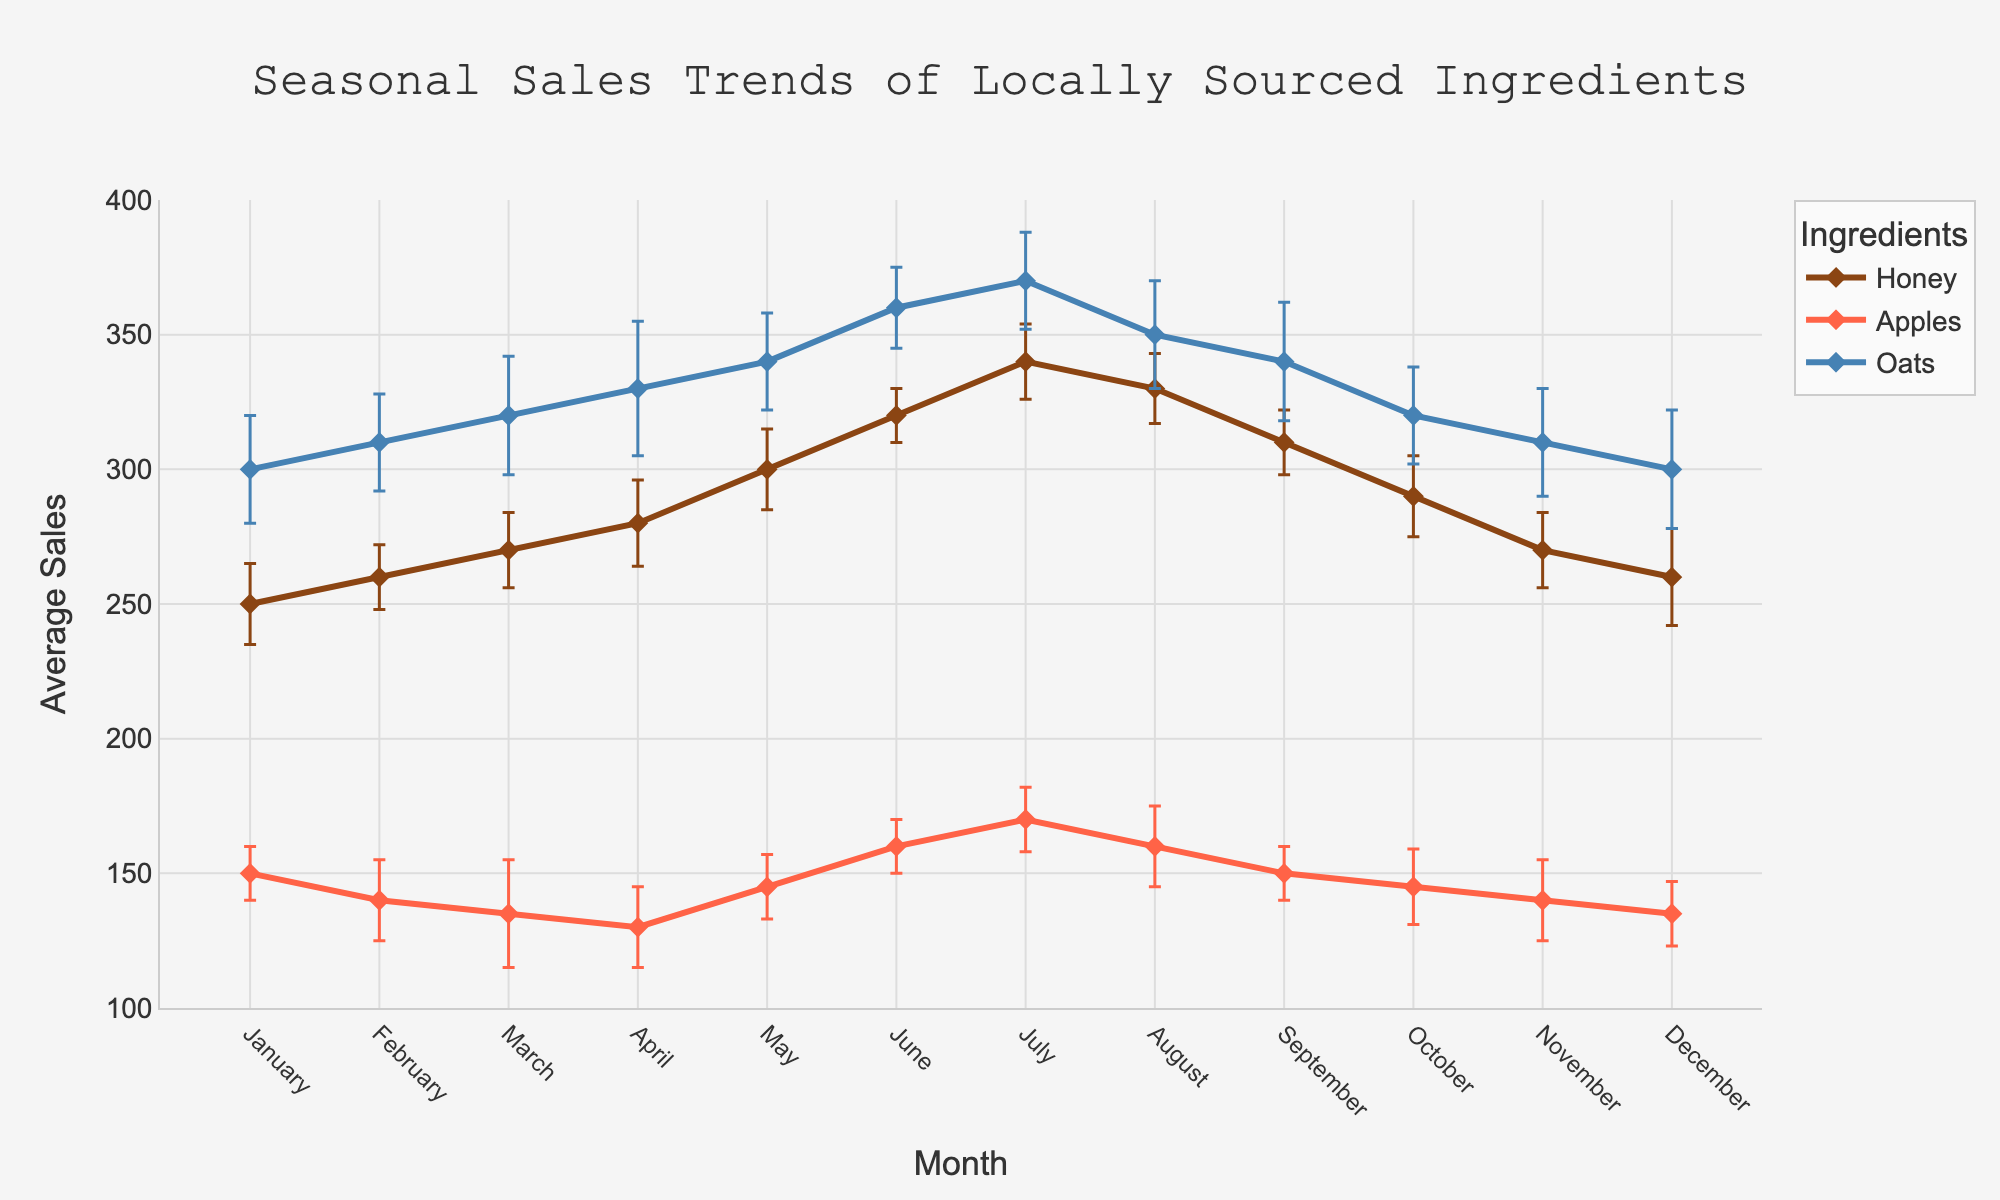what is the title of the figure? The title is located at the top-center of the figure in a larger font size and a different color than the other text. It provides the main information about what the figure represents.
Answer: Seasonal Sales Trends of Locally Sourced Ingredients Which ingredient has the highest average sales in June? Locate the data points for June and identify the ingredient with the highest vertical position on the y-axis. This represents the highest average sales for June.
Answer: Oats How does the average sales trend for Honey change from May to July? Find the data points for Honey in May, June, and July. Observe the direction of the line connecting these points. The sales for Honey increase, moving from May to July.
Answer: It increases Which month has the lowest sales of Apples, and what is the value? Identify the data points for Apples across all months and find the one with the lowest vertical position on the y-axis. Read the corresponding y-axis value to determine the sales.
Answer: March, 135 How do the error bars in March for Honey compare to those in June? Locate the error bars for Honey in March and June. Compare their lengths to see which month’s error bars are longer, indicating a higher standard deviation.
Answer: March's error bars are longer Which ingredient shows the most consistent trend in sales across all months? Examine all the lines for each ingredient. The ingredient whose line has the least variation (fluctuations) across months is the most consistent.
Answer: Honey What is the average sales increase of Oats from January to June? Find the sales values for Oats in January and June. Calculate the difference between these two values.
Answer: (360 - 300) = 60 Which ingredient has the highest sales standard deviation in December, and what is its value? Look at the error bars for all ingredients in December. The longest error bar corresponds to the highest standard deviation. The standard deviation value is given alongside the error bar for that month.
Answer: Honey, 18 